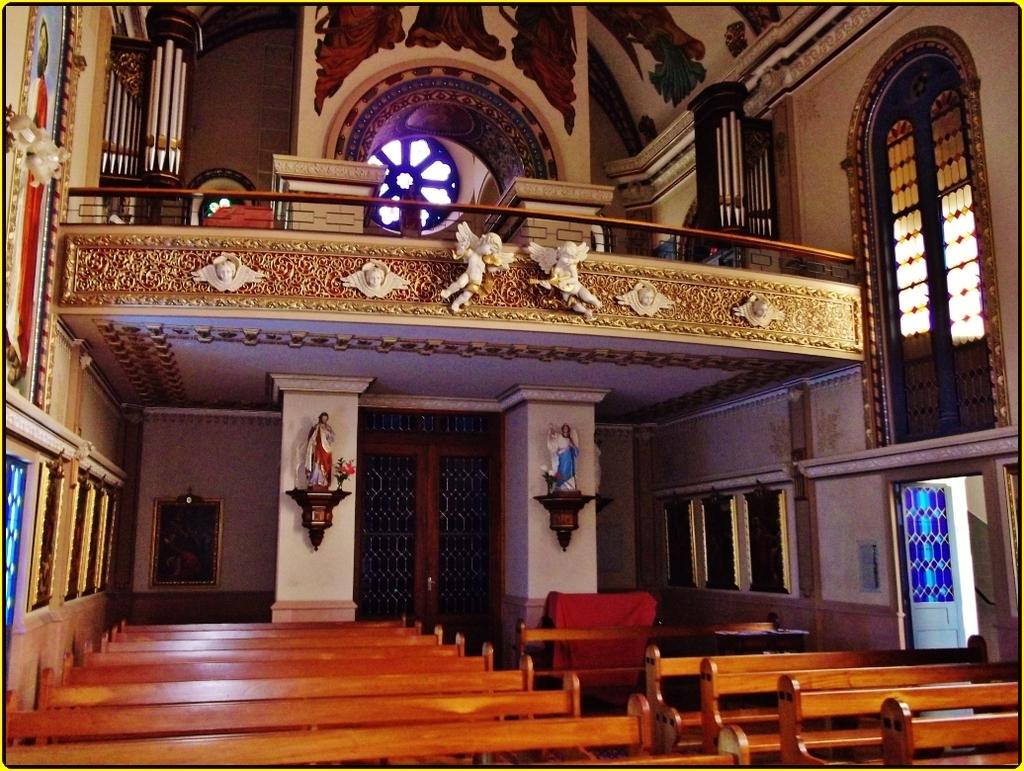What type of furniture is present in the room? There are benches in the room. What are the primary means of entering or exiting the room? There are doors in the room. What allows natural light to enter the room? There are windows in the room. What type of decorative objects can be seen on the walls? There are statues attached to the wall. What type of metal is used to make the scarf in the image? There is no scarf present in the image, and therefore no metal can be associated with it. How much toothpaste is visible on the statues in the image? There is no toothpaste present in the image, and the statues are not associated with any toothpaste. 